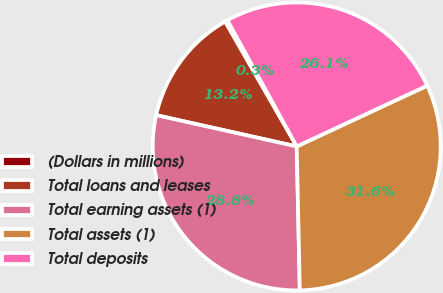Convert chart. <chart><loc_0><loc_0><loc_500><loc_500><pie_chart><fcel>(Dollars in millions)<fcel>Total loans and leases<fcel>Total earning assets (1)<fcel>Total assets (1)<fcel>Total deposits<nl><fcel>0.3%<fcel>13.22%<fcel>28.83%<fcel>31.59%<fcel>26.06%<nl></chart> 